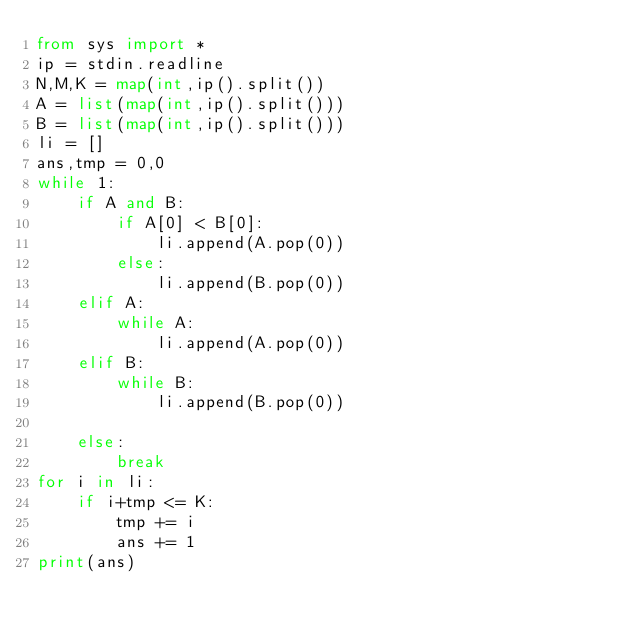<code> <loc_0><loc_0><loc_500><loc_500><_Python_>from sys import *
ip = stdin.readline
N,M,K = map(int,ip().split())
A = list(map(int,ip().split()))
B = list(map(int,ip().split()))
li = []
ans,tmp = 0,0
while 1:
    if A and B:
        if A[0] < B[0]:
            li.append(A.pop(0))
        else:
            li.append(B.pop(0))
    elif A:
        while A:
            li.append(A.pop(0))
    elif B:
        while B:
            li.append(B.pop(0))
 
    else:
        break
for i in li:
    if i+tmp <= K:
        tmp += i
        ans += 1
print(ans)</code> 